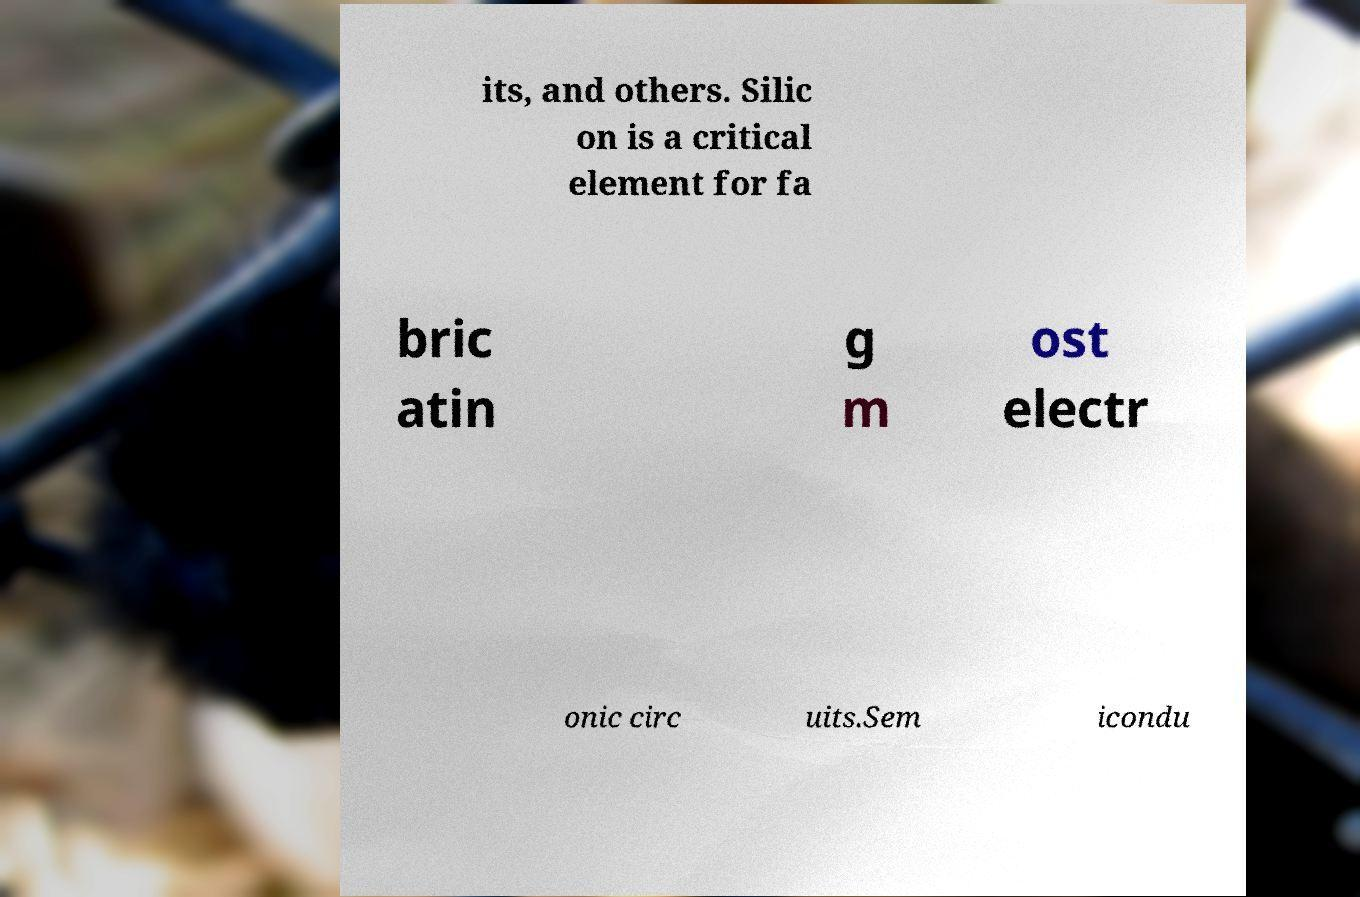Could you assist in decoding the text presented in this image and type it out clearly? its, and others. Silic on is a critical element for fa bric atin g m ost electr onic circ uits.Sem icondu 